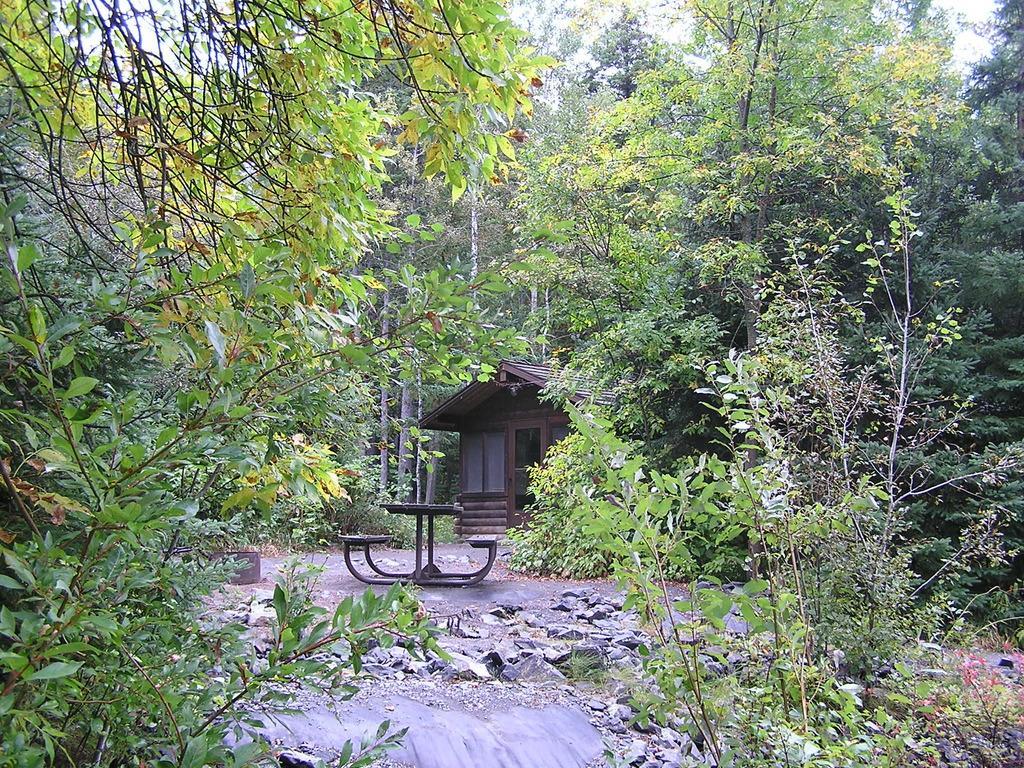Could you give a brief overview of what you see in this image? In this image I can see the plants. In the background I can see the table and benches and also the house. I can see many trees and the sky. 